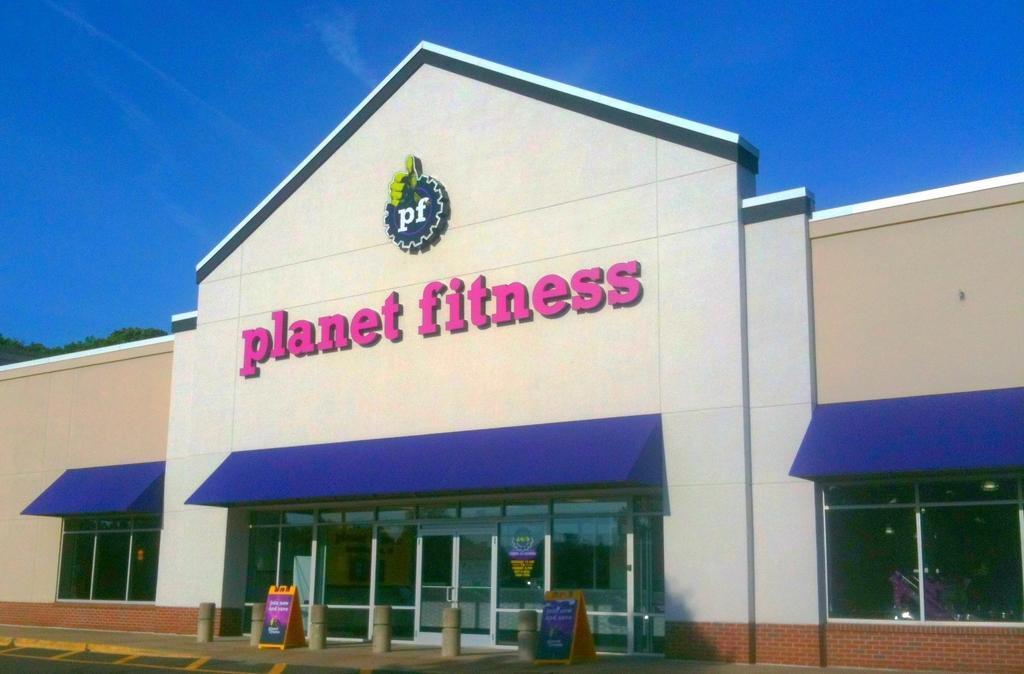Describe this image in one or two sentences. In this picture we can see a building with windows, sun shades, banners, road, trees and in the background we can see the sky. 